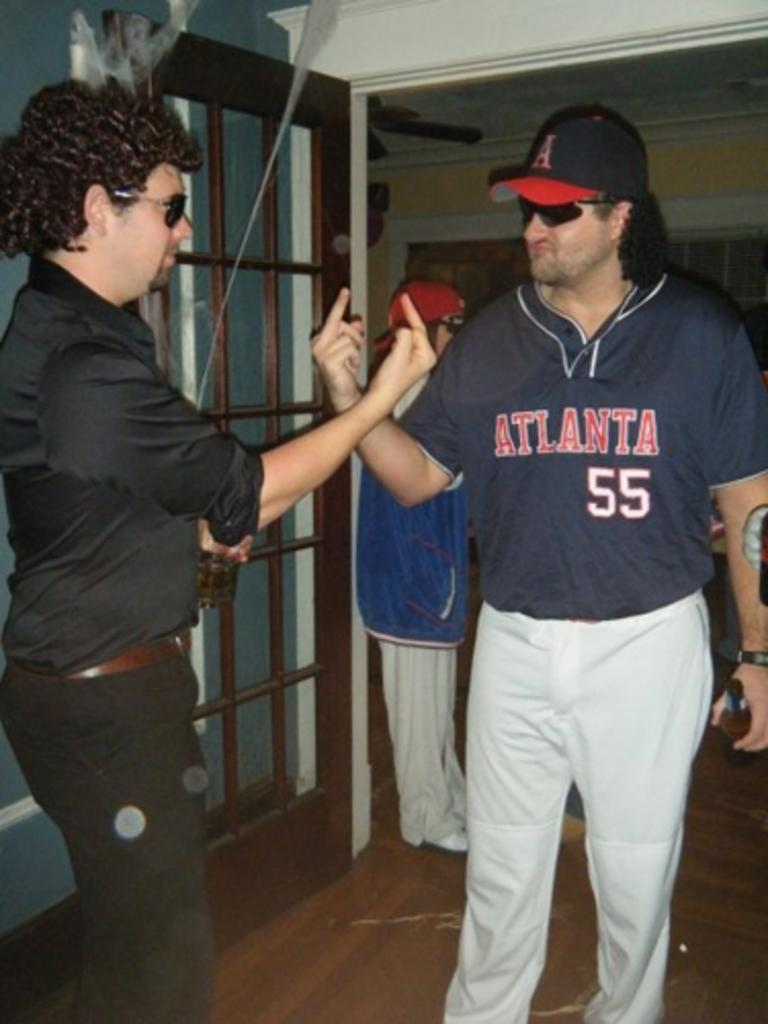<image>
Render a clear and concise summary of the photo. Two men, one of which is wearing a jersey for an Atlanta team with the number 55, flip off each other. 